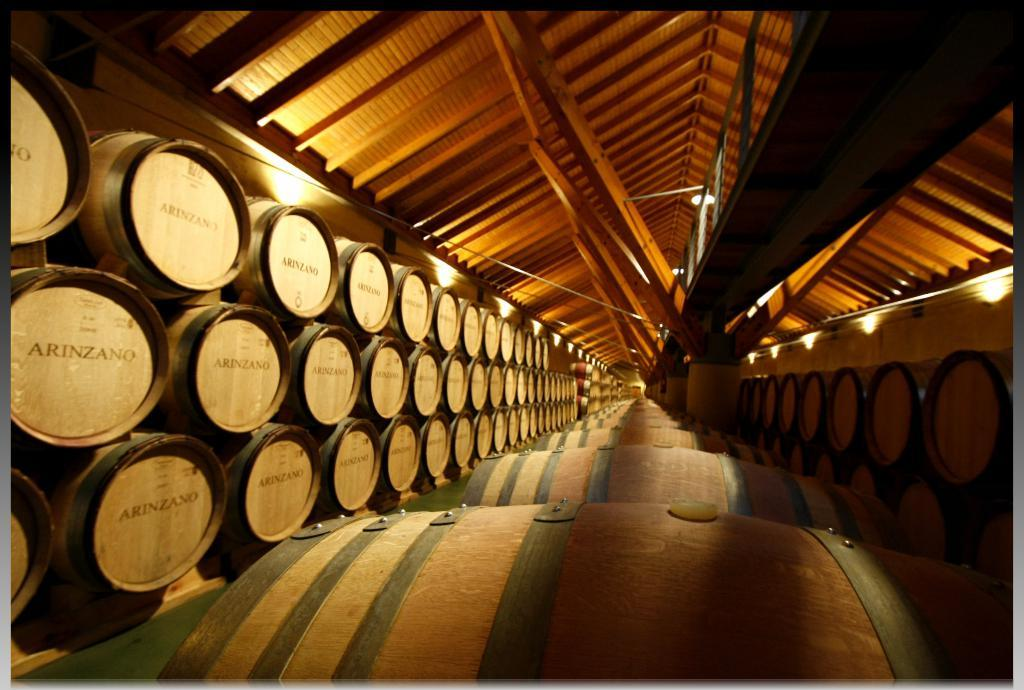<image>
Offer a succinct explanation of the picture presented. Several rows of Arinzano barrels in a covered shed area. 